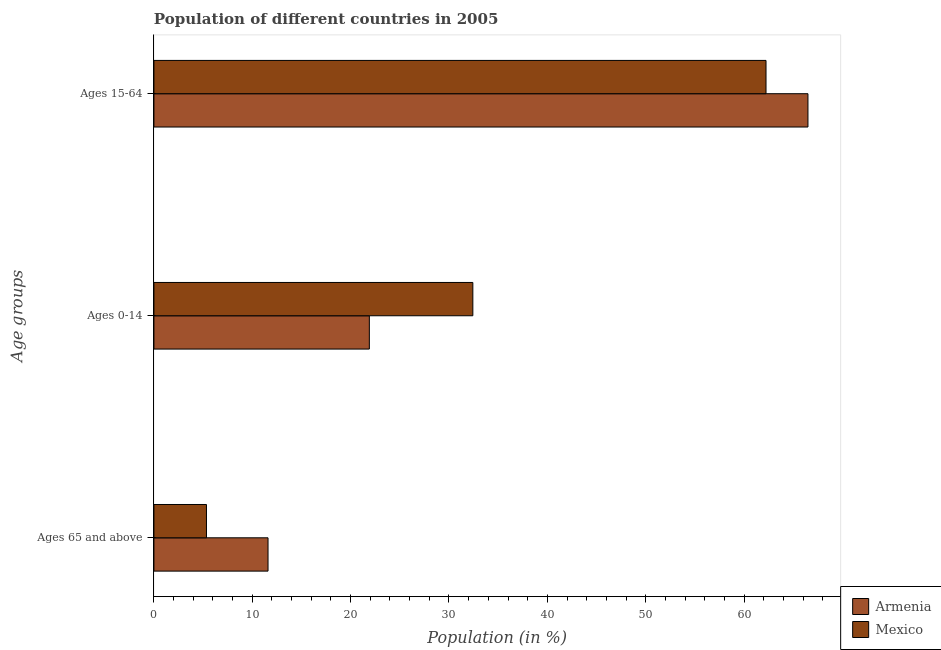Are the number of bars per tick equal to the number of legend labels?
Provide a succinct answer. Yes. How many bars are there on the 2nd tick from the top?
Keep it short and to the point. 2. How many bars are there on the 3rd tick from the bottom?
Your answer should be very brief. 2. What is the label of the 1st group of bars from the top?
Your answer should be compact. Ages 15-64. What is the percentage of population within the age-group 15-64 in Armenia?
Make the answer very short. 66.5. Across all countries, what is the maximum percentage of population within the age-group of 65 and above?
Offer a terse response. 11.6. Across all countries, what is the minimum percentage of population within the age-group of 65 and above?
Make the answer very short. 5.34. In which country was the percentage of population within the age-group of 65 and above maximum?
Ensure brevity in your answer.  Armenia. What is the total percentage of population within the age-group 0-14 in the graph?
Your answer should be compact. 54.33. What is the difference between the percentage of population within the age-group of 65 and above in Mexico and that in Armenia?
Your response must be concise. -6.26. What is the difference between the percentage of population within the age-group 0-14 in Armenia and the percentage of population within the age-group 15-64 in Mexico?
Keep it short and to the point. -40.33. What is the average percentage of population within the age-group of 65 and above per country?
Offer a very short reply. 8.47. What is the difference between the percentage of population within the age-group 15-64 and percentage of population within the age-group 0-14 in Mexico?
Offer a very short reply. 29.81. What is the ratio of the percentage of population within the age-group 15-64 in Armenia to that in Mexico?
Provide a short and direct response. 1.07. Is the difference between the percentage of population within the age-group 0-14 in Armenia and Mexico greater than the difference between the percentage of population within the age-group of 65 and above in Armenia and Mexico?
Your answer should be very brief. No. What is the difference between the highest and the second highest percentage of population within the age-group 15-64?
Ensure brevity in your answer.  4.26. What is the difference between the highest and the lowest percentage of population within the age-group 0-14?
Make the answer very short. 10.52. Is it the case that in every country, the sum of the percentage of population within the age-group of 65 and above and percentage of population within the age-group 0-14 is greater than the percentage of population within the age-group 15-64?
Provide a succinct answer. No. How many bars are there?
Your response must be concise. 6. Are all the bars in the graph horizontal?
Your answer should be very brief. Yes. Are the values on the major ticks of X-axis written in scientific E-notation?
Your answer should be very brief. No. Does the graph contain any zero values?
Provide a short and direct response. No. Does the graph contain grids?
Offer a very short reply. No. How are the legend labels stacked?
Give a very brief answer. Vertical. What is the title of the graph?
Your answer should be compact. Population of different countries in 2005. Does "Egypt, Arab Rep." appear as one of the legend labels in the graph?
Provide a short and direct response. No. What is the label or title of the X-axis?
Your answer should be compact. Population (in %). What is the label or title of the Y-axis?
Offer a very short reply. Age groups. What is the Population (in %) of Armenia in Ages 65 and above?
Give a very brief answer. 11.6. What is the Population (in %) of Mexico in Ages 65 and above?
Give a very brief answer. 5.34. What is the Population (in %) of Armenia in Ages 0-14?
Provide a short and direct response. 21.9. What is the Population (in %) of Mexico in Ages 0-14?
Provide a short and direct response. 32.42. What is the Population (in %) in Armenia in Ages 15-64?
Provide a succinct answer. 66.5. What is the Population (in %) of Mexico in Ages 15-64?
Your answer should be very brief. 62.23. Across all Age groups, what is the maximum Population (in %) of Armenia?
Make the answer very short. 66.5. Across all Age groups, what is the maximum Population (in %) in Mexico?
Offer a terse response. 62.23. Across all Age groups, what is the minimum Population (in %) in Armenia?
Offer a very short reply. 11.6. Across all Age groups, what is the minimum Population (in %) in Mexico?
Offer a terse response. 5.34. What is the total Population (in %) in Mexico in the graph?
Your response must be concise. 100. What is the difference between the Population (in %) of Armenia in Ages 65 and above and that in Ages 0-14?
Offer a terse response. -10.3. What is the difference between the Population (in %) in Mexico in Ages 65 and above and that in Ages 0-14?
Ensure brevity in your answer.  -27.08. What is the difference between the Population (in %) in Armenia in Ages 65 and above and that in Ages 15-64?
Give a very brief answer. -54.9. What is the difference between the Population (in %) of Mexico in Ages 65 and above and that in Ages 15-64?
Keep it short and to the point. -56.89. What is the difference between the Population (in %) of Armenia in Ages 0-14 and that in Ages 15-64?
Provide a succinct answer. -44.59. What is the difference between the Population (in %) of Mexico in Ages 0-14 and that in Ages 15-64?
Offer a terse response. -29.81. What is the difference between the Population (in %) in Armenia in Ages 65 and above and the Population (in %) in Mexico in Ages 0-14?
Give a very brief answer. -20.82. What is the difference between the Population (in %) of Armenia in Ages 65 and above and the Population (in %) of Mexico in Ages 15-64?
Keep it short and to the point. -50.63. What is the difference between the Population (in %) in Armenia in Ages 0-14 and the Population (in %) in Mexico in Ages 15-64?
Ensure brevity in your answer.  -40.33. What is the average Population (in %) in Armenia per Age groups?
Make the answer very short. 33.33. What is the average Population (in %) in Mexico per Age groups?
Your answer should be very brief. 33.33. What is the difference between the Population (in %) of Armenia and Population (in %) of Mexico in Ages 65 and above?
Your response must be concise. 6.26. What is the difference between the Population (in %) of Armenia and Population (in %) of Mexico in Ages 0-14?
Your response must be concise. -10.52. What is the difference between the Population (in %) in Armenia and Population (in %) in Mexico in Ages 15-64?
Give a very brief answer. 4.26. What is the ratio of the Population (in %) of Armenia in Ages 65 and above to that in Ages 0-14?
Offer a very short reply. 0.53. What is the ratio of the Population (in %) in Mexico in Ages 65 and above to that in Ages 0-14?
Your answer should be very brief. 0.16. What is the ratio of the Population (in %) of Armenia in Ages 65 and above to that in Ages 15-64?
Ensure brevity in your answer.  0.17. What is the ratio of the Population (in %) of Mexico in Ages 65 and above to that in Ages 15-64?
Provide a short and direct response. 0.09. What is the ratio of the Population (in %) of Armenia in Ages 0-14 to that in Ages 15-64?
Offer a very short reply. 0.33. What is the ratio of the Population (in %) of Mexico in Ages 0-14 to that in Ages 15-64?
Your answer should be compact. 0.52. What is the difference between the highest and the second highest Population (in %) in Armenia?
Provide a succinct answer. 44.59. What is the difference between the highest and the second highest Population (in %) in Mexico?
Your answer should be compact. 29.81. What is the difference between the highest and the lowest Population (in %) in Armenia?
Your answer should be compact. 54.9. What is the difference between the highest and the lowest Population (in %) of Mexico?
Provide a succinct answer. 56.89. 